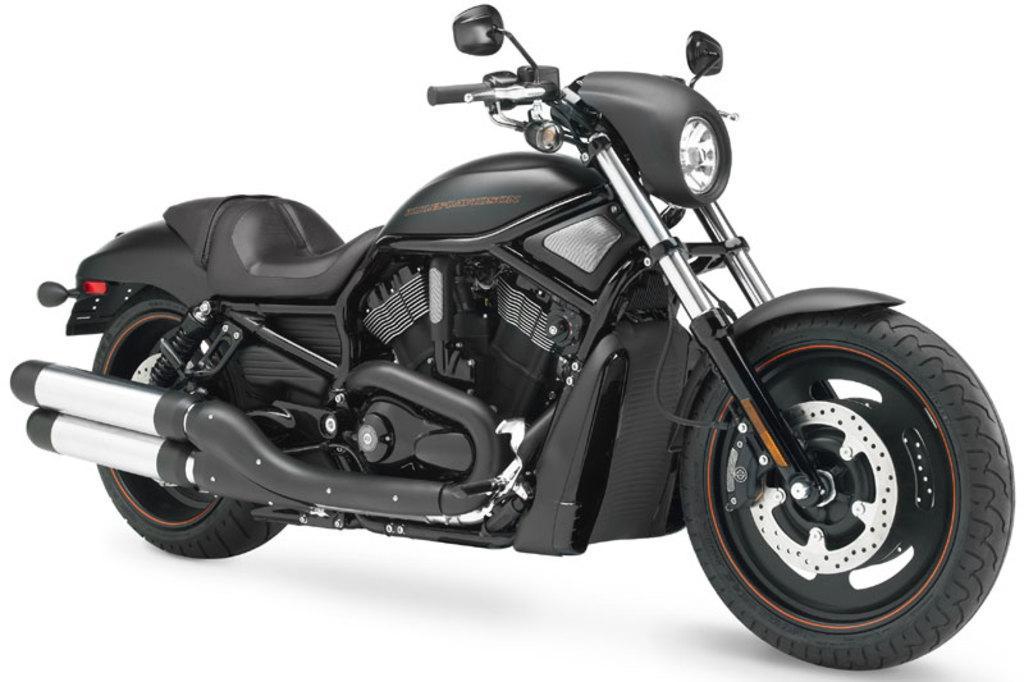Could you give a brief overview of what you see in this image? In this picture I can see the vehicle. 